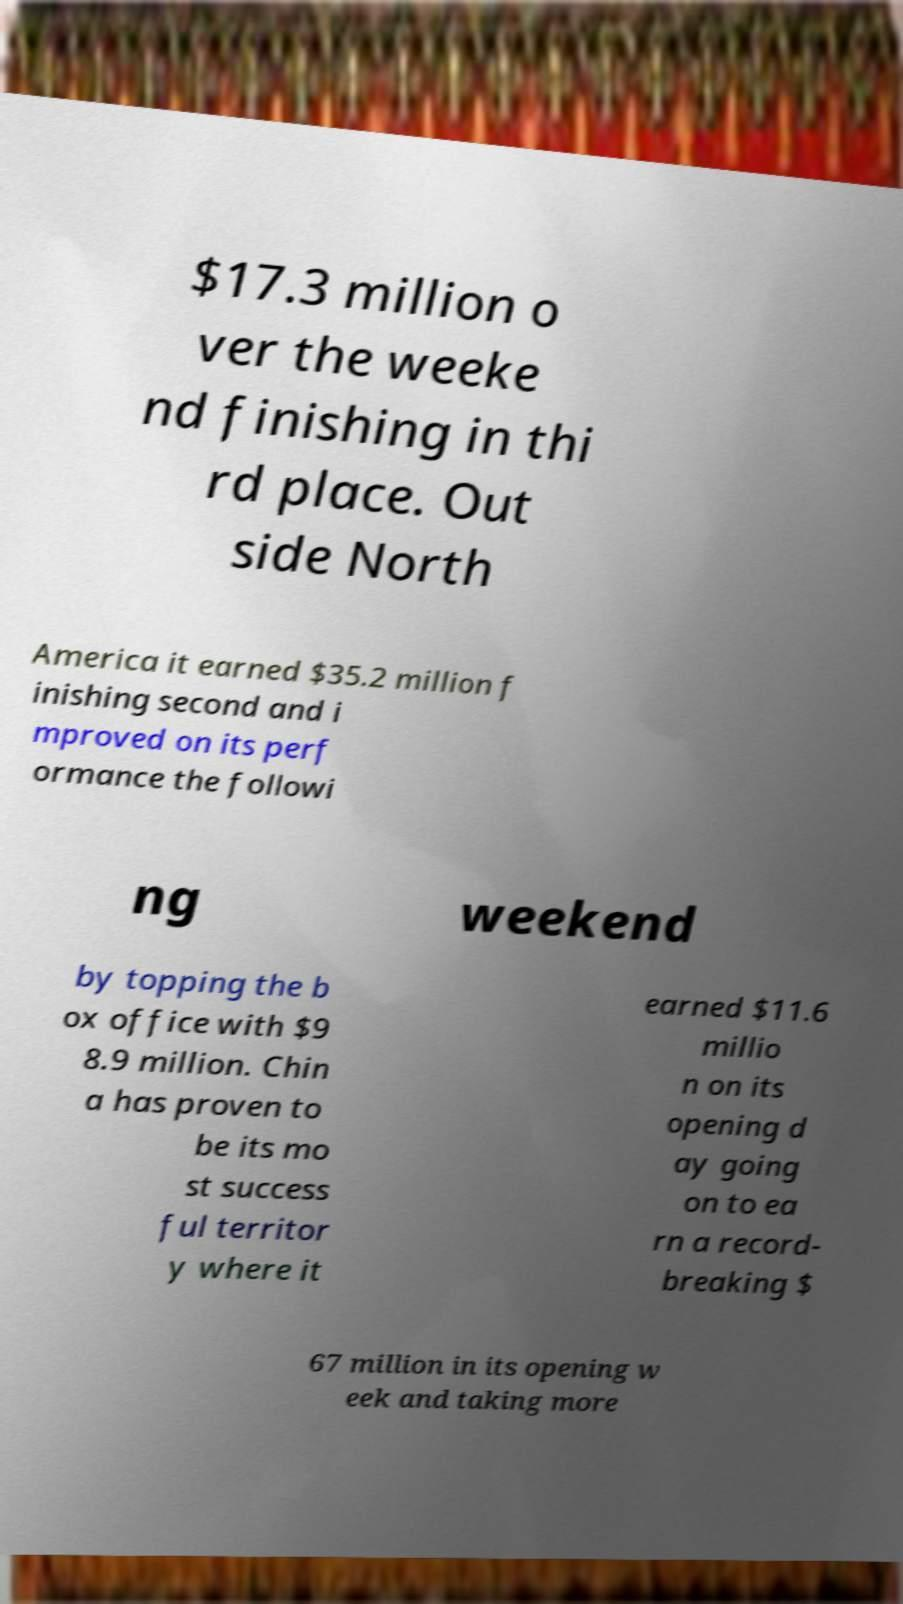What messages or text are displayed in this image? I need them in a readable, typed format. $17.3 million o ver the weeke nd finishing in thi rd place. Out side North America it earned $35.2 million f inishing second and i mproved on its perf ormance the followi ng weekend by topping the b ox office with $9 8.9 million. Chin a has proven to be its mo st success ful territor y where it earned $11.6 millio n on its opening d ay going on to ea rn a record- breaking $ 67 million in its opening w eek and taking more 